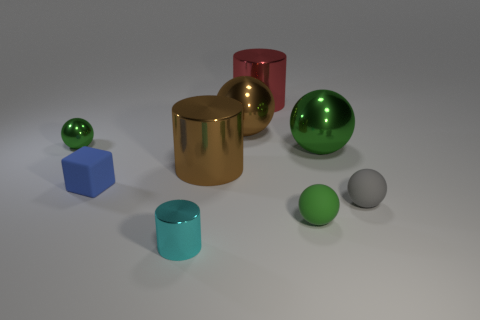There is a rubber sphere on the left side of the tiny gray ball; is its color the same as the small shiny ball?
Keep it short and to the point. Yes. Are there any other things that have the same color as the small shiny ball?
Provide a short and direct response. Yes. Is the number of rubber balls behind the red thing greater than the number of big metallic objects?
Offer a very short reply. No. Does the red cylinder have the same size as the green matte thing?
Keep it short and to the point. No. What is the material of the brown thing that is the same shape as the green matte object?
Give a very brief answer. Metal. Is there any other thing that has the same material as the big red cylinder?
Make the answer very short. Yes. How many green objects are either shiny cylinders or rubber objects?
Keep it short and to the point. 1. There is a tiny green object behind the blue matte object; what is it made of?
Give a very brief answer. Metal. Is the number of big rubber cylinders greater than the number of matte spheres?
Ensure brevity in your answer.  No. Do the brown object that is behind the tiny green shiny object and the small gray object have the same shape?
Offer a very short reply. Yes. 